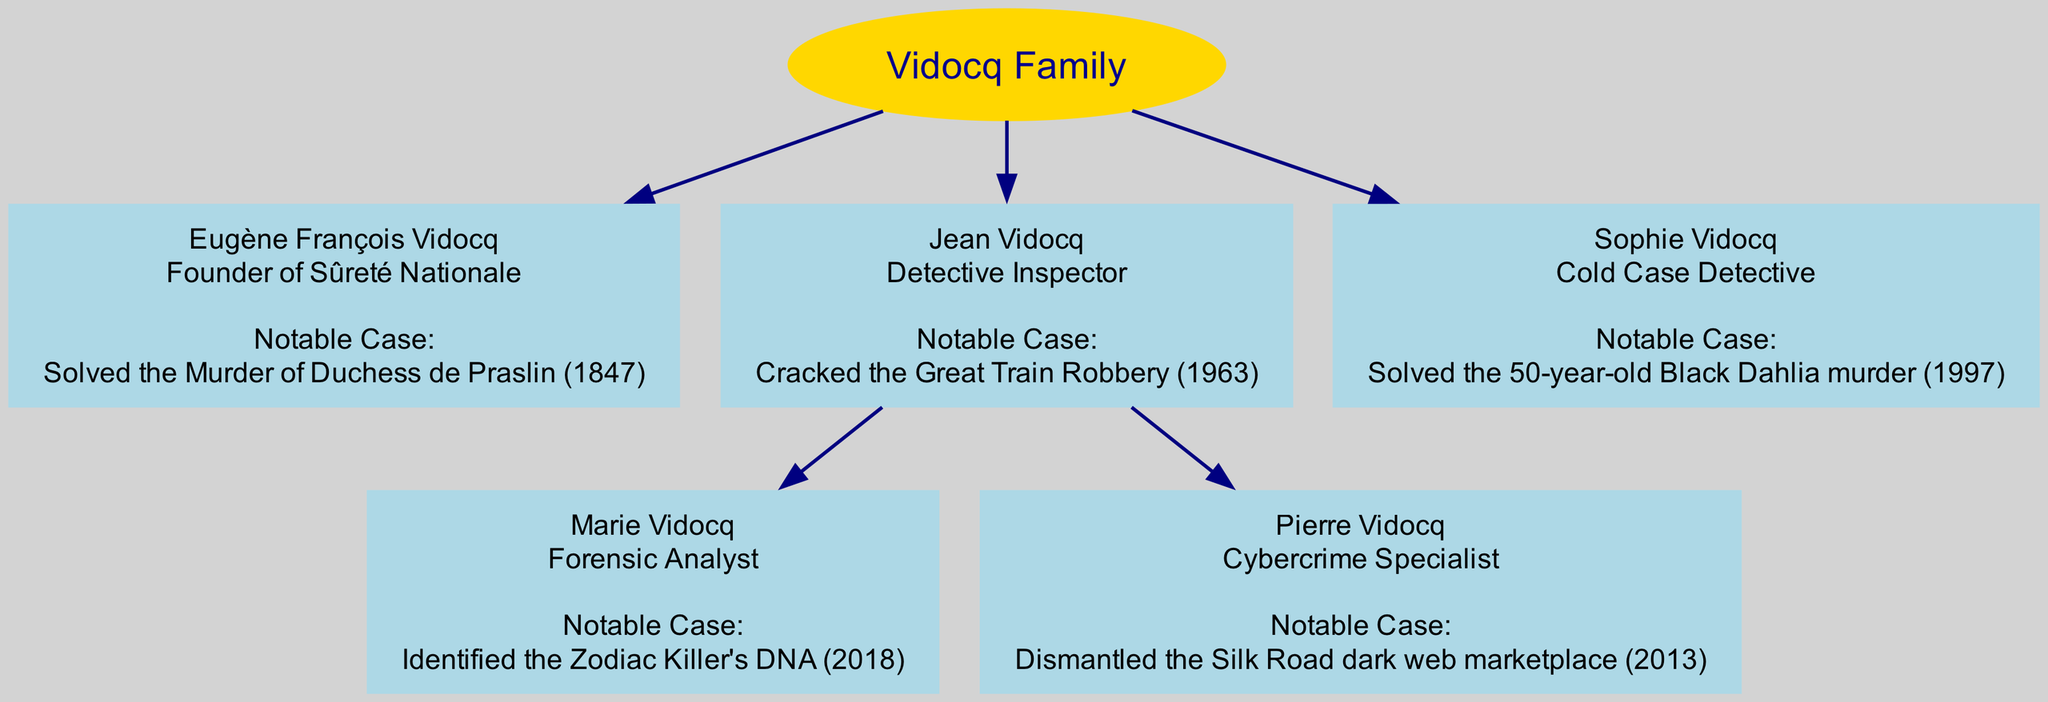What is the role of Eugène François Vidocq? The diagram shows that Eugène François Vidocq's role is "Founder of Sûreté Nationale," as mentioned in his node label.
Answer: Founder of Sûreté Nationale How many children does Jean Vidocq have? By examining the node for Jean Vidocq, it indicates he has two children: Marie Vidocq and Pierre Vidocq.
Answer: 2 What notable case did Sophie Vidocq solve? Looking at the node for Sophie Vidocq, it states she solved the "50-year-old Black Dahlia murder (1997)."
Answer: 50-year-old Black Dahlia murder (1997) Who is the Cybercrime Specialist in the family? The diagram identifies Pierre Vidocq as the Cybercrime Specialist, based on the information shared in his node.
Answer: Pierre Vidocq Which family member identified the Zodiac Killer's DNA? The node for Marie Vidocq specifies that she identified the Zodiac Killer's DNA (2018), clearly showing her unique contribution in the family lineage.
Answer: Marie Vidocq Which generation features the founder of Sûreté Nationale? The term "Founder of Sûreté Nationale" is associated with Eugène François Vidocq, who is listed in the first generation of the family tree.
Answer: First generation What role is associated with the notable case of the Great Train Robbery? Jean Vidocq's node states that he is a "Detective Inspector" and that he cracked the Great Train Robbery (1963), connecting his role directly to this case.
Answer: Detective Inspector How many generations are represented in the family tree? The diagram reflects three distinct generations, with at least one member in each generation.
Answer: 3 Who solved the murder of the Duchess de Praslin? According to the node for Eugène François Vidocq, he solved the murder of the Duchess de Praslin in 1847.
Answer: Eugène François Vidocq 